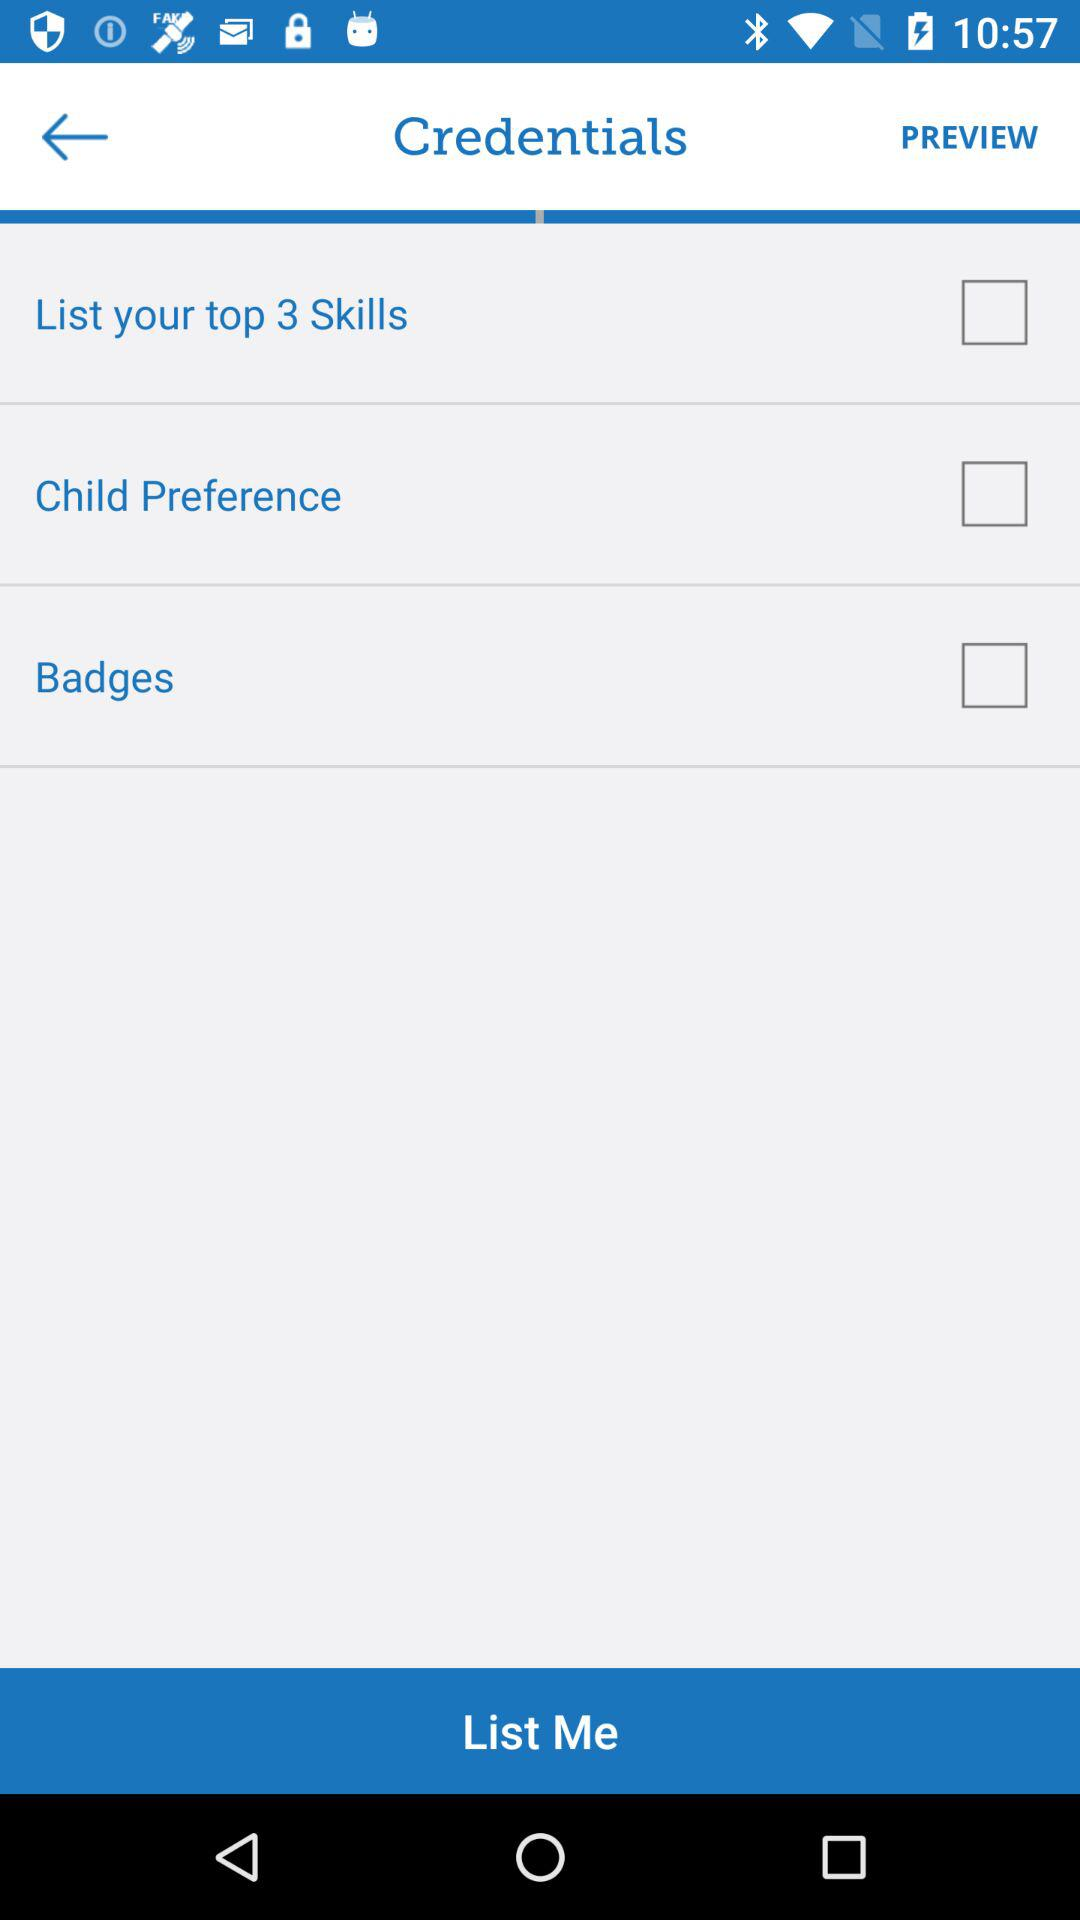What is the status of "Child Preference"? The status of "Child Preference" is "off". 